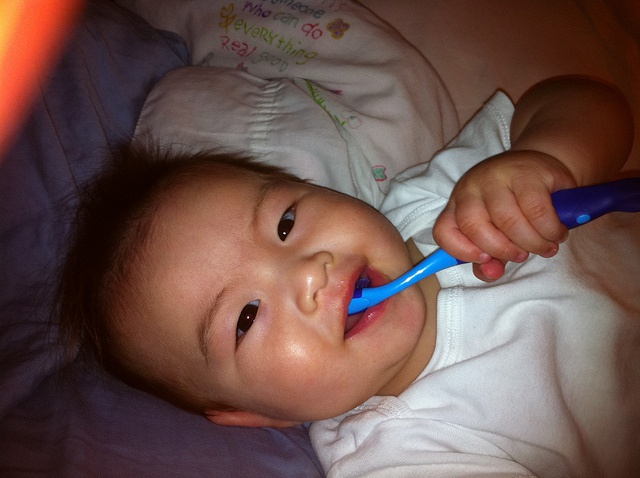Describe the objects in this image and their specific colors. I can see people in orange, brown, black, maroon, and darkgray tones, bed in orange, black, gray, and maroon tones, couch in orange, black, gray, and maroon tones, and toothbrush in orange, black, gray, navy, and blue tones in this image. 